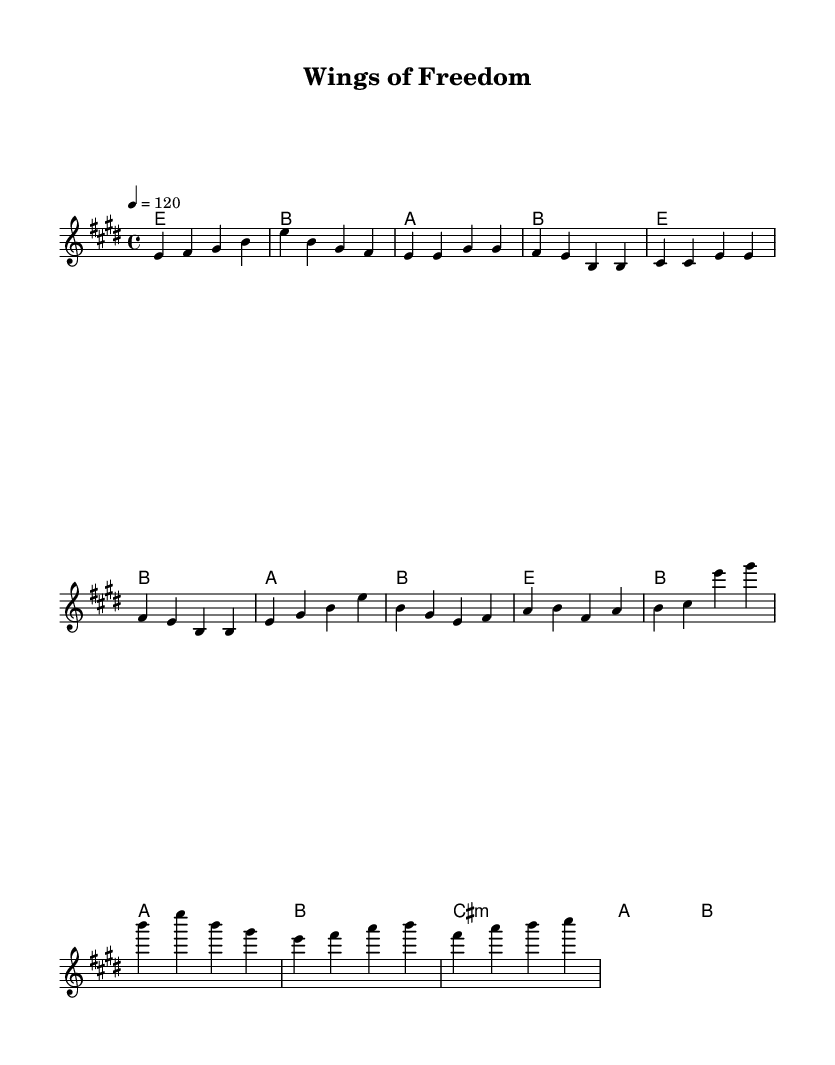What is the key signature of this music? The key signature is indicated by the sharp symbols at the beginning of the staff. In this case, there are four sharps, which corresponds to the key of E major.
Answer: E major What is the time signature of this music? The time signature is presented at the beginning of the piece, denoting how many beats are in each measure. Here, it is indicated as 4/4, meaning there are four beats per measure.
Answer: 4/4 What is the tempo marking in this piece? The tempo marking provides the speed of the music; in this score, it is indicated by "4 = 120," meaning the quarter note is to be played at 120 beats per minute.
Answer: 120 What three chords are used in the verse section? To find the answer, we can look at the chord section under the verse notes. The three chords indicated are E major, B major, and A major, as seen in the chord progression for the verse.
Answer: E major, B major, A major What does the phrase "wings of freedom" indicate in the context of this song? The phrase "wings of freedom" is the title and central theme, suggesting a focus on the exhilaration of flying and exploration, which is reflected throughout the lyrics and musical elements. This phrase invokes imagery of liberation and adventure, characteristic of classic rock anthems.
Answer: Exploration and exhilaration What is the lyrical theme of the chorus? The chorus discusses themes of soaring and breaking free, which directly correlates with flying and the thrill of liberation. By interpreting the lines in the chorus, it emphasizes the experience of viewing the world from above and the feeling of freedom associated with it.
Answer: Soaring and liberation 